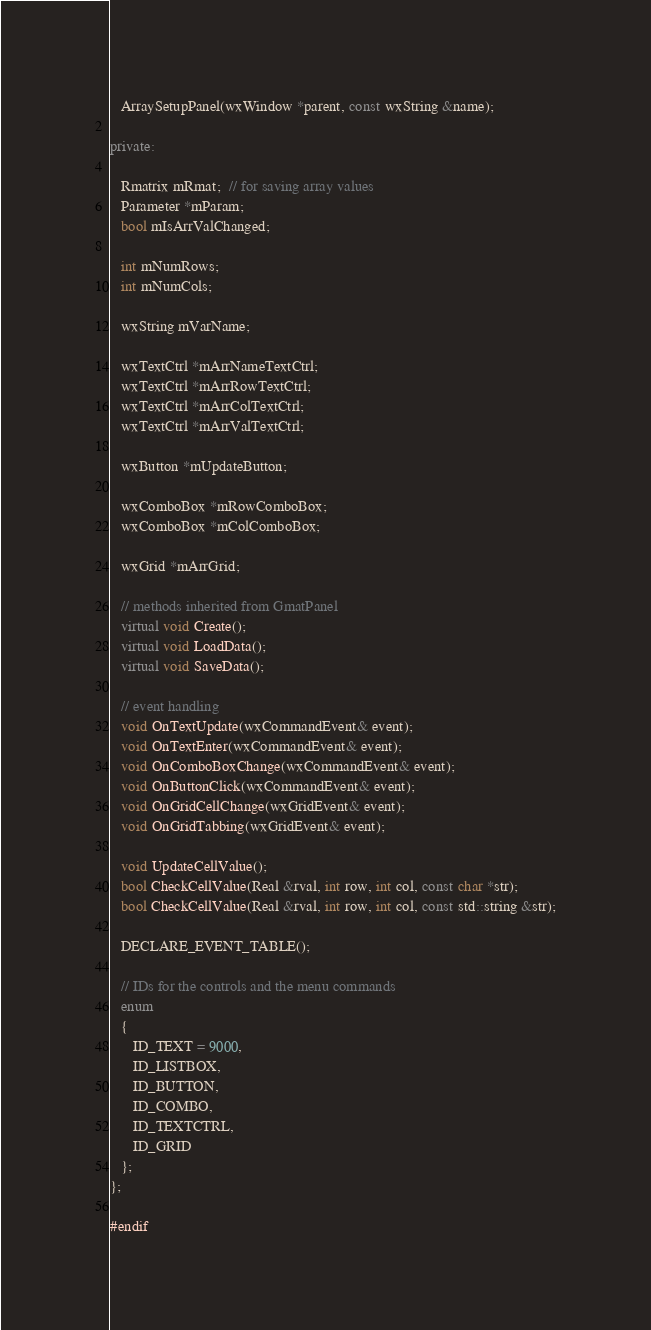Convert code to text. <code><loc_0><loc_0><loc_500><loc_500><_C++_>   ArraySetupPanel(wxWindow *parent, const wxString &name); 
   
private:
   
   Rmatrix mRmat;  // for saving array values
   Parameter *mParam;
   bool mIsArrValChanged;
   
   int mNumRows;
   int mNumCols;
   
   wxString mVarName;
   
   wxTextCtrl *mArrNameTextCtrl;
   wxTextCtrl *mArrRowTextCtrl;
   wxTextCtrl *mArrColTextCtrl;
   wxTextCtrl *mArrValTextCtrl;
   
   wxButton *mUpdateButton;
   
   wxComboBox *mRowComboBox;
   wxComboBox *mColComboBox;
   
   wxGrid *mArrGrid;
   
   // methods inherited from GmatPanel
   virtual void Create();
   virtual void LoadData();
   virtual void SaveData();
   
   // event handling
   void OnTextUpdate(wxCommandEvent& event);
   void OnTextEnter(wxCommandEvent& event);
   void OnComboBoxChange(wxCommandEvent& event);
   void OnButtonClick(wxCommandEvent& event);
   void OnGridCellChange(wxGridEvent& event);
   void OnGridTabbing(wxGridEvent& event);
   
   void UpdateCellValue();
   bool CheckCellValue(Real &rval, int row, int col, const char *str);
   bool CheckCellValue(Real &rval, int row, int col, const std::string &str);
   
   DECLARE_EVENT_TABLE();
   
   // IDs for the controls and the menu commands
   enum
   {     
      ID_TEXT = 9000,
      ID_LISTBOX,
      ID_BUTTON,
      ID_COMBO,
      ID_TEXTCTRL,
      ID_GRID
   };
};

#endif
</code> 